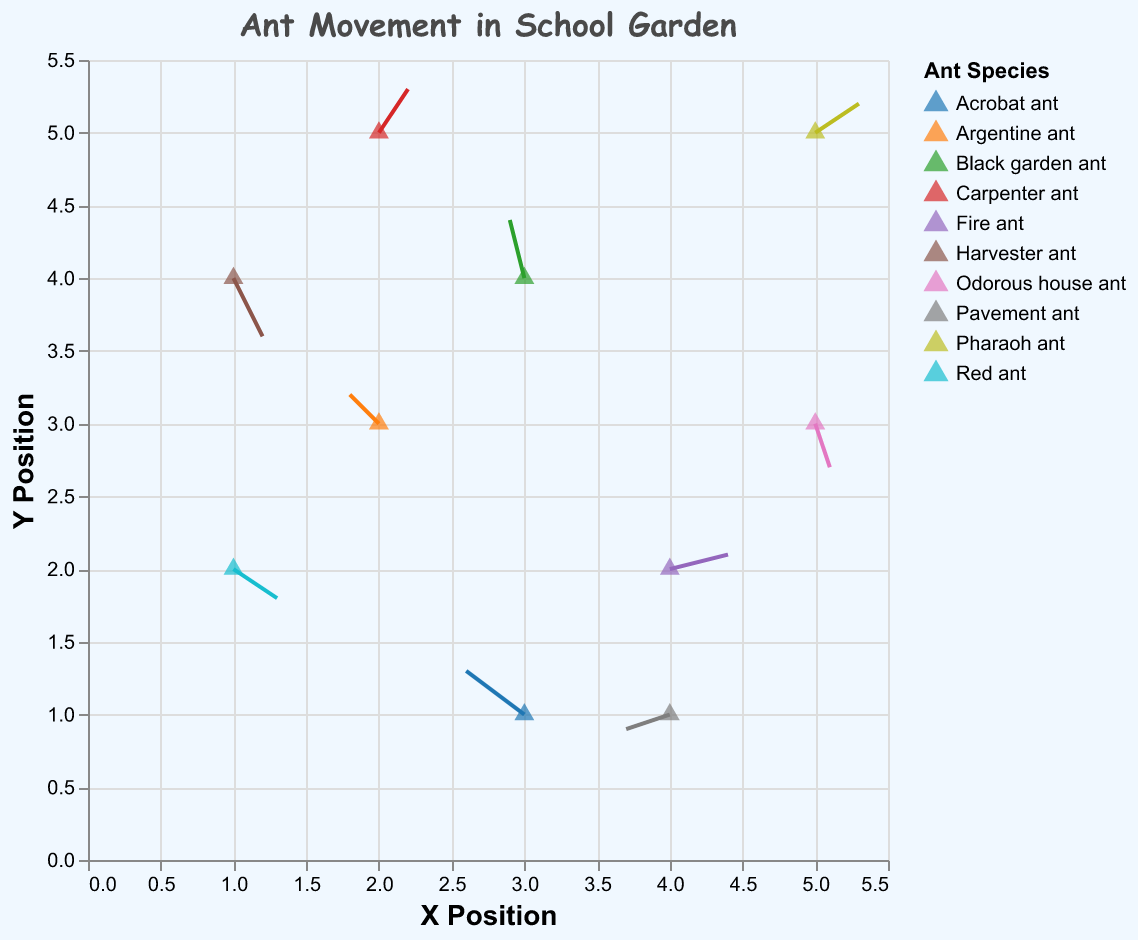How many different ant species are represented in the plot? There are unique colors and labels used in the plot to differentiate each ant species. By counting them, we identify there are 10 different species.
Answer: 10 What is the title of the plot? The title is displayed clearly at the top of the plot.
Answer: Ant Movement in School Garden Which ant species moves the fastest? To determine the fastest, we need to find the longest vector (u, v) when combining both direction and magnitude. The Fire ant has the values (0.4, 0.1), which results in the longest vector of sqrt(0.4^2 + 0.1^2) = 0.41.
Answer: Fire ant What is the X position of the Carpenter ant? The X position can be found directly under the 'Carpenter ant' in the plot.
Answer: 2 Which ant species moves in a downward direction (negative Y direction)? We need to look for negative values in the v-component. The Red ant, Harvester ant, and Odorous house ant all move downward.
Answer: Red ant, Harvester ant, Odorous house ant What is the total distance moved by the Acrobat ant? By calculating the square root of the sum of the squares of the u and v components: sqrt((-0.4)^2 + (0.3)^2) = sqrt(0.16 + 0.09) = sqrt(0.25) = 0.5.
Answer: 0.5 units Which ant species has the greatest positive movement in the Y direction? We need to find the species with the highest positive v value. The Black garden ant has a v value of 0.4.
Answer: Black garden ant How many ants move in the negative X direction? We count the ants with negative u values: Black garden ant, Pavement ant, Argentine ant, and Acrobat ant.
Answer: 4 What are the coordinates of the starting point for the Fire ant? Look directly at the initial values for the Fire ant in the plot.
Answer: (4, 2) Compare the movement direction of the Argentine ant and the Pharaoh ant. Which one is moving more upward? Argentine ant has a v value of 0.2 and Pharaoh ant has a v value of 0.2. Since these values are equal, they both move equally upward.
Answer: They are equal 